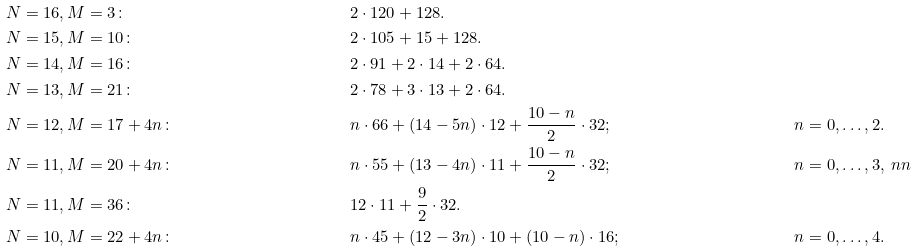<formula> <loc_0><loc_0><loc_500><loc_500>& \, N = 1 6 , M = 3 \colon & & 2 \cdot 1 2 0 + 1 2 8 . \\ & \, N = 1 5 , M = 1 0 \colon & & 2 \cdot 1 0 5 + 1 5 + 1 2 8 . \\ & \, N = 1 4 , M = 1 6 \colon & & 2 \cdot 9 1 + 2 \cdot 1 4 + 2 \cdot 6 4 . \\ & \, N = 1 3 , M = 2 1 \colon & & 2 \cdot 7 8 + 3 \cdot 1 3 + 2 \cdot 6 4 . \\ & \, N = 1 2 , M = 1 7 + 4 n \colon & & n \cdot 6 6 + ( 1 4 - 5 n ) \cdot 1 2 + \frac { 1 0 - n } { 2 } \cdot 3 2 ; & & n = 0 , \dots , 2 . \\ & \, N = 1 1 , M = 2 0 + 4 n \colon & & n \cdot 5 5 + ( 1 3 - 4 n ) \cdot 1 1 + \frac { 1 0 - n } { 2 } \cdot 3 2 ; & & n = 0 , \dots , 3 , \ n n \\ & \, N = 1 1 , M = 3 6 \colon & & 1 2 \cdot 1 1 + \frac { 9 } { 2 } \cdot 3 2 . \\ & \, N = 1 0 , M = 2 2 + 4 n \colon & & n \cdot 4 5 + ( 1 2 - 3 n ) \cdot 1 0 + ( 1 0 - n ) \cdot 1 6 ; & & n = 0 , \dots , 4 .</formula> 